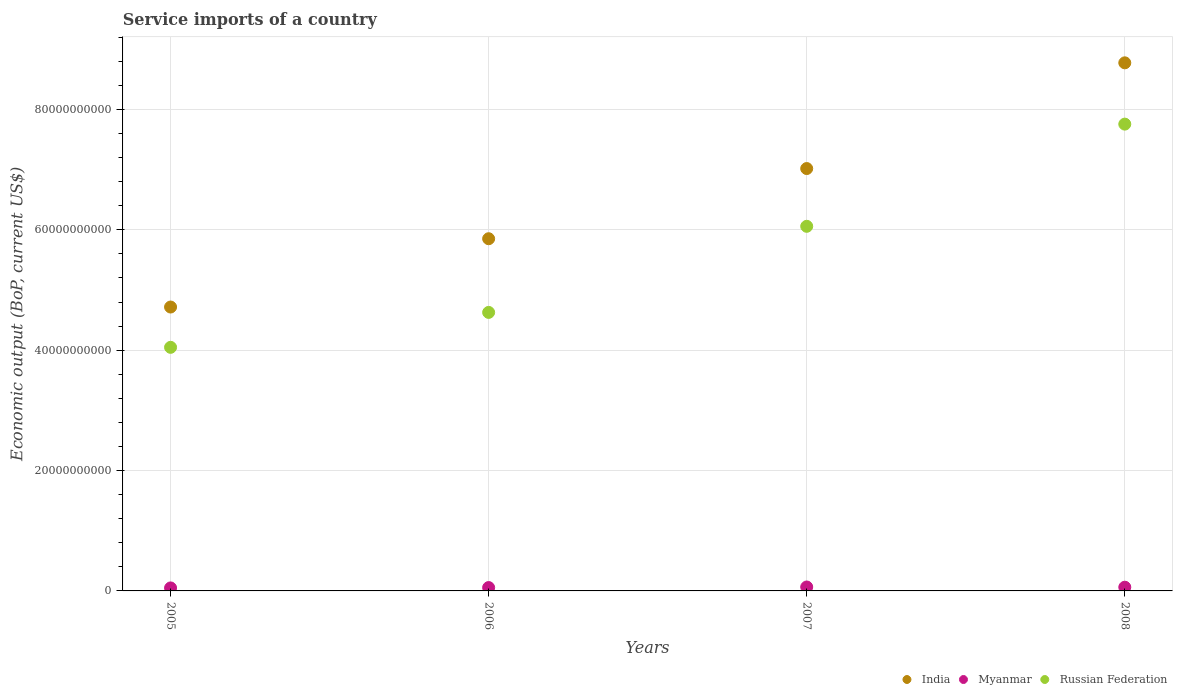How many different coloured dotlines are there?
Keep it short and to the point. 3. What is the service imports in India in 2007?
Keep it short and to the point. 7.02e+1. Across all years, what is the maximum service imports in India?
Give a very brief answer. 8.77e+1. Across all years, what is the minimum service imports in Russian Federation?
Your answer should be compact. 4.05e+1. In which year was the service imports in Russian Federation minimum?
Keep it short and to the point. 2005. What is the total service imports in Myanmar in the graph?
Give a very brief answer. 2.32e+09. What is the difference between the service imports in Russian Federation in 2006 and that in 2008?
Your response must be concise. -3.13e+1. What is the difference between the service imports in Russian Federation in 2005 and the service imports in India in 2007?
Make the answer very short. -2.97e+1. What is the average service imports in Russian Federation per year?
Keep it short and to the point. 5.62e+1. In the year 2005, what is the difference between the service imports in Russian Federation and service imports in India?
Keep it short and to the point. -6.70e+09. What is the ratio of the service imports in India in 2007 to that in 2008?
Offer a terse response. 0.8. What is the difference between the highest and the second highest service imports in India?
Offer a very short reply. 1.76e+1. What is the difference between the highest and the lowest service imports in Myanmar?
Provide a succinct answer. 1.56e+08. Is the sum of the service imports in India in 2006 and 2007 greater than the maximum service imports in Russian Federation across all years?
Give a very brief answer. Yes. Does the service imports in India monotonically increase over the years?
Make the answer very short. Yes. Is the service imports in India strictly greater than the service imports in Myanmar over the years?
Your response must be concise. Yes. Is the service imports in India strictly less than the service imports in Myanmar over the years?
Your response must be concise. No. What is the difference between two consecutive major ticks on the Y-axis?
Your response must be concise. 2.00e+1. Are the values on the major ticks of Y-axis written in scientific E-notation?
Ensure brevity in your answer.  No. Does the graph contain any zero values?
Make the answer very short. No. Does the graph contain grids?
Your answer should be very brief. Yes. Where does the legend appear in the graph?
Ensure brevity in your answer.  Bottom right. How are the legend labels stacked?
Offer a terse response. Horizontal. What is the title of the graph?
Offer a terse response. Service imports of a country. Does "Trinidad and Tobago" appear as one of the legend labels in the graph?
Offer a terse response. No. What is the label or title of the X-axis?
Your response must be concise. Years. What is the label or title of the Y-axis?
Provide a succinct answer. Economic output (BoP, current US$). What is the Economic output (BoP, current US$) in India in 2005?
Your response must be concise. 4.72e+1. What is the Economic output (BoP, current US$) of Myanmar in 2005?
Keep it short and to the point. 4.97e+08. What is the Economic output (BoP, current US$) in Russian Federation in 2005?
Your response must be concise. 4.05e+1. What is the Economic output (BoP, current US$) in India in 2006?
Ensure brevity in your answer.  5.85e+1. What is the Economic output (BoP, current US$) of Myanmar in 2006?
Give a very brief answer. 5.57e+08. What is the Economic output (BoP, current US$) of Russian Federation in 2006?
Your answer should be compact. 4.63e+1. What is the Economic output (BoP, current US$) in India in 2007?
Offer a terse response. 7.02e+1. What is the Economic output (BoP, current US$) in Myanmar in 2007?
Your answer should be very brief. 6.53e+08. What is the Economic output (BoP, current US$) in Russian Federation in 2007?
Provide a short and direct response. 6.06e+1. What is the Economic output (BoP, current US$) of India in 2008?
Your response must be concise. 8.77e+1. What is the Economic output (BoP, current US$) of Myanmar in 2008?
Provide a short and direct response. 6.17e+08. What is the Economic output (BoP, current US$) in Russian Federation in 2008?
Give a very brief answer. 7.76e+1. Across all years, what is the maximum Economic output (BoP, current US$) of India?
Provide a succinct answer. 8.77e+1. Across all years, what is the maximum Economic output (BoP, current US$) in Myanmar?
Keep it short and to the point. 6.53e+08. Across all years, what is the maximum Economic output (BoP, current US$) in Russian Federation?
Provide a succinct answer. 7.76e+1. Across all years, what is the minimum Economic output (BoP, current US$) of India?
Give a very brief answer. 4.72e+1. Across all years, what is the minimum Economic output (BoP, current US$) of Myanmar?
Ensure brevity in your answer.  4.97e+08. Across all years, what is the minimum Economic output (BoP, current US$) in Russian Federation?
Ensure brevity in your answer.  4.05e+1. What is the total Economic output (BoP, current US$) of India in the graph?
Offer a terse response. 2.64e+11. What is the total Economic output (BoP, current US$) in Myanmar in the graph?
Offer a terse response. 2.32e+09. What is the total Economic output (BoP, current US$) of Russian Federation in the graph?
Make the answer very short. 2.25e+11. What is the difference between the Economic output (BoP, current US$) in India in 2005 and that in 2006?
Your answer should be very brief. -1.13e+1. What is the difference between the Economic output (BoP, current US$) of Myanmar in 2005 and that in 2006?
Provide a succinct answer. -6.01e+07. What is the difference between the Economic output (BoP, current US$) in Russian Federation in 2005 and that in 2006?
Your response must be concise. -5.80e+09. What is the difference between the Economic output (BoP, current US$) in India in 2005 and that in 2007?
Your answer should be very brief. -2.30e+1. What is the difference between the Economic output (BoP, current US$) of Myanmar in 2005 and that in 2007?
Your answer should be very brief. -1.56e+08. What is the difference between the Economic output (BoP, current US$) of Russian Federation in 2005 and that in 2007?
Your answer should be compact. -2.01e+1. What is the difference between the Economic output (BoP, current US$) of India in 2005 and that in 2008?
Ensure brevity in your answer.  -4.06e+1. What is the difference between the Economic output (BoP, current US$) of Myanmar in 2005 and that in 2008?
Offer a terse response. -1.20e+08. What is the difference between the Economic output (BoP, current US$) of Russian Federation in 2005 and that in 2008?
Your response must be concise. -3.71e+1. What is the difference between the Economic output (BoP, current US$) of India in 2006 and that in 2007?
Offer a terse response. -1.17e+1. What is the difference between the Economic output (BoP, current US$) in Myanmar in 2006 and that in 2007?
Offer a terse response. -9.60e+07. What is the difference between the Economic output (BoP, current US$) in Russian Federation in 2006 and that in 2007?
Offer a very short reply. -1.43e+1. What is the difference between the Economic output (BoP, current US$) of India in 2006 and that in 2008?
Keep it short and to the point. -2.92e+1. What is the difference between the Economic output (BoP, current US$) of Myanmar in 2006 and that in 2008?
Provide a succinct answer. -6.01e+07. What is the difference between the Economic output (BoP, current US$) of Russian Federation in 2006 and that in 2008?
Your response must be concise. -3.13e+1. What is the difference between the Economic output (BoP, current US$) in India in 2007 and that in 2008?
Make the answer very short. -1.76e+1. What is the difference between the Economic output (BoP, current US$) in Myanmar in 2007 and that in 2008?
Make the answer very short. 3.59e+07. What is the difference between the Economic output (BoP, current US$) of Russian Federation in 2007 and that in 2008?
Offer a terse response. -1.70e+1. What is the difference between the Economic output (BoP, current US$) of India in 2005 and the Economic output (BoP, current US$) of Myanmar in 2006?
Your answer should be compact. 4.66e+1. What is the difference between the Economic output (BoP, current US$) of India in 2005 and the Economic output (BoP, current US$) of Russian Federation in 2006?
Ensure brevity in your answer.  8.93e+08. What is the difference between the Economic output (BoP, current US$) of Myanmar in 2005 and the Economic output (BoP, current US$) of Russian Federation in 2006?
Provide a succinct answer. -4.58e+1. What is the difference between the Economic output (BoP, current US$) of India in 2005 and the Economic output (BoP, current US$) of Myanmar in 2007?
Your answer should be very brief. 4.65e+1. What is the difference between the Economic output (BoP, current US$) of India in 2005 and the Economic output (BoP, current US$) of Russian Federation in 2007?
Ensure brevity in your answer.  -1.34e+1. What is the difference between the Economic output (BoP, current US$) of Myanmar in 2005 and the Economic output (BoP, current US$) of Russian Federation in 2007?
Provide a succinct answer. -6.01e+1. What is the difference between the Economic output (BoP, current US$) in India in 2005 and the Economic output (BoP, current US$) in Myanmar in 2008?
Provide a short and direct response. 4.65e+1. What is the difference between the Economic output (BoP, current US$) in India in 2005 and the Economic output (BoP, current US$) in Russian Federation in 2008?
Make the answer very short. -3.04e+1. What is the difference between the Economic output (BoP, current US$) of Myanmar in 2005 and the Economic output (BoP, current US$) of Russian Federation in 2008?
Your answer should be compact. -7.71e+1. What is the difference between the Economic output (BoP, current US$) in India in 2006 and the Economic output (BoP, current US$) in Myanmar in 2007?
Make the answer very short. 5.79e+1. What is the difference between the Economic output (BoP, current US$) of India in 2006 and the Economic output (BoP, current US$) of Russian Federation in 2007?
Your response must be concise. -2.06e+09. What is the difference between the Economic output (BoP, current US$) of Myanmar in 2006 and the Economic output (BoP, current US$) of Russian Federation in 2007?
Keep it short and to the point. -6.00e+1. What is the difference between the Economic output (BoP, current US$) of India in 2006 and the Economic output (BoP, current US$) of Myanmar in 2008?
Your answer should be compact. 5.79e+1. What is the difference between the Economic output (BoP, current US$) in India in 2006 and the Economic output (BoP, current US$) in Russian Federation in 2008?
Provide a short and direct response. -1.90e+1. What is the difference between the Economic output (BoP, current US$) of Myanmar in 2006 and the Economic output (BoP, current US$) of Russian Federation in 2008?
Provide a succinct answer. -7.70e+1. What is the difference between the Economic output (BoP, current US$) of India in 2007 and the Economic output (BoP, current US$) of Myanmar in 2008?
Your response must be concise. 6.96e+1. What is the difference between the Economic output (BoP, current US$) in India in 2007 and the Economic output (BoP, current US$) in Russian Federation in 2008?
Offer a very short reply. -7.38e+09. What is the difference between the Economic output (BoP, current US$) in Myanmar in 2007 and the Economic output (BoP, current US$) in Russian Federation in 2008?
Give a very brief answer. -7.69e+1. What is the average Economic output (BoP, current US$) of India per year?
Your answer should be compact. 6.59e+1. What is the average Economic output (BoP, current US$) in Myanmar per year?
Your response must be concise. 5.81e+08. What is the average Economic output (BoP, current US$) in Russian Federation per year?
Make the answer very short. 5.62e+1. In the year 2005, what is the difference between the Economic output (BoP, current US$) in India and Economic output (BoP, current US$) in Myanmar?
Your answer should be very brief. 4.67e+1. In the year 2005, what is the difference between the Economic output (BoP, current US$) of India and Economic output (BoP, current US$) of Russian Federation?
Your answer should be compact. 6.70e+09. In the year 2005, what is the difference between the Economic output (BoP, current US$) in Myanmar and Economic output (BoP, current US$) in Russian Federation?
Provide a succinct answer. -4.00e+1. In the year 2006, what is the difference between the Economic output (BoP, current US$) in India and Economic output (BoP, current US$) in Myanmar?
Your answer should be very brief. 5.80e+1. In the year 2006, what is the difference between the Economic output (BoP, current US$) of India and Economic output (BoP, current US$) of Russian Federation?
Provide a short and direct response. 1.22e+1. In the year 2006, what is the difference between the Economic output (BoP, current US$) of Myanmar and Economic output (BoP, current US$) of Russian Federation?
Your response must be concise. -4.57e+1. In the year 2007, what is the difference between the Economic output (BoP, current US$) in India and Economic output (BoP, current US$) in Myanmar?
Your response must be concise. 6.95e+1. In the year 2007, what is the difference between the Economic output (BoP, current US$) in India and Economic output (BoP, current US$) in Russian Federation?
Give a very brief answer. 9.60e+09. In the year 2007, what is the difference between the Economic output (BoP, current US$) in Myanmar and Economic output (BoP, current US$) in Russian Federation?
Your answer should be compact. -5.99e+1. In the year 2008, what is the difference between the Economic output (BoP, current US$) of India and Economic output (BoP, current US$) of Myanmar?
Provide a succinct answer. 8.71e+1. In the year 2008, what is the difference between the Economic output (BoP, current US$) in India and Economic output (BoP, current US$) in Russian Federation?
Make the answer very short. 1.02e+1. In the year 2008, what is the difference between the Economic output (BoP, current US$) in Myanmar and Economic output (BoP, current US$) in Russian Federation?
Your answer should be very brief. -7.69e+1. What is the ratio of the Economic output (BoP, current US$) in India in 2005 to that in 2006?
Give a very brief answer. 0.81. What is the ratio of the Economic output (BoP, current US$) of Myanmar in 2005 to that in 2006?
Give a very brief answer. 0.89. What is the ratio of the Economic output (BoP, current US$) of Russian Federation in 2005 to that in 2006?
Ensure brevity in your answer.  0.87. What is the ratio of the Economic output (BoP, current US$) of India in 2005 to that in 2007?
Make the answer very short. 0.67. What is the ratio of the Economic output (BoP, current US$) of Myanmar in 2005 to that in 2007?
Keep it short and to the point. 0.76. What is the ratio of the Economic output (BoP, current US$) in Russian Federation in 2005 to that in 2007?
Offer a terse response. 0.67. What is the ratio of the Economic output (BoP, current US$) of India in 2005 to that in 2008?
Make the answer very short. 0.54. What is the ratio of the Economic output (BoP, current US$) in Myanmar in 2005 to that in 2008?
Offer a terse response. 0.81. What is the ratio of the Economic output (BoP, current US$) of Russian Federation in 2005 to that in 2008?
Ensure brevity in your answer.  0.52. What is the ratio of the Economic output (BoP, current US$) in India in 2006 to that in 2007?
Give a very brief answer. 0.83. What is the ratio of the Economic output (BoP, current US$) of Myanmar in 2006 to that in 2007?
Your answer should be very brief. 0.85. What is the ratio of the Economic output (BoP, current US$) of Russian Federation in 2006 to that in 2007?
Your answer should be very brief. 0.76. What is the ratio of the Economic output (BoP, current US$) in India in 2006 to that in 2008?
Your answer should be very brief. 0.67. What is the ratio of the Economic output (BoP, current US$) of Myanmar in 2006 to that in 2008?
Your answer should be compact. 0.9. What is the ratio of the Economic output (BoP, current US$) in Russian Federation in 2006 to that in 2008?
Provide a short and direct response. 0.6. What is the ratio of the Economic output (BoP, current US$) in India in 2007 to that in 2008?
Provide a succinct answer. 0.8. What is the ratio of the Economic output (BoP, current US$) in Myanmar in 2007 to that in 2008?
Offer a terse response. 1.06. What is the ratio of the Economic output (BoP, current US$) in Russian Federation in 2007 to that in 2008?
Your answer should be very brief. 0.78. What is the difference between the highest and the second highest Economic output (BoP, current US$) in India?
Your answer should be compact. 1.76e+1. What is the difference between the highest and the second highest Economic output (BoP, current US$) of Myanmar?
Keep it short and to the point. 3.59e+07. What is the difference between the highest and the second highest Economic output (BoP, current US$) of Russian Federation?
Your response must be concise. 1.70e+1. What is the difference between the highest and the lowest Economic output (BoP, current US$) in India?
Provide a short and direct response. 4.06e+1. What is the difference between the highest and the lowest Economic output (BoP, current US$) in Myanmar?
Your response must be concise. 1.56e+08. What is the difference between the highest and the lowest Economic output (BoP, current US$) in Russian Federation?
Give a very brief answer. 3.71e+1. 